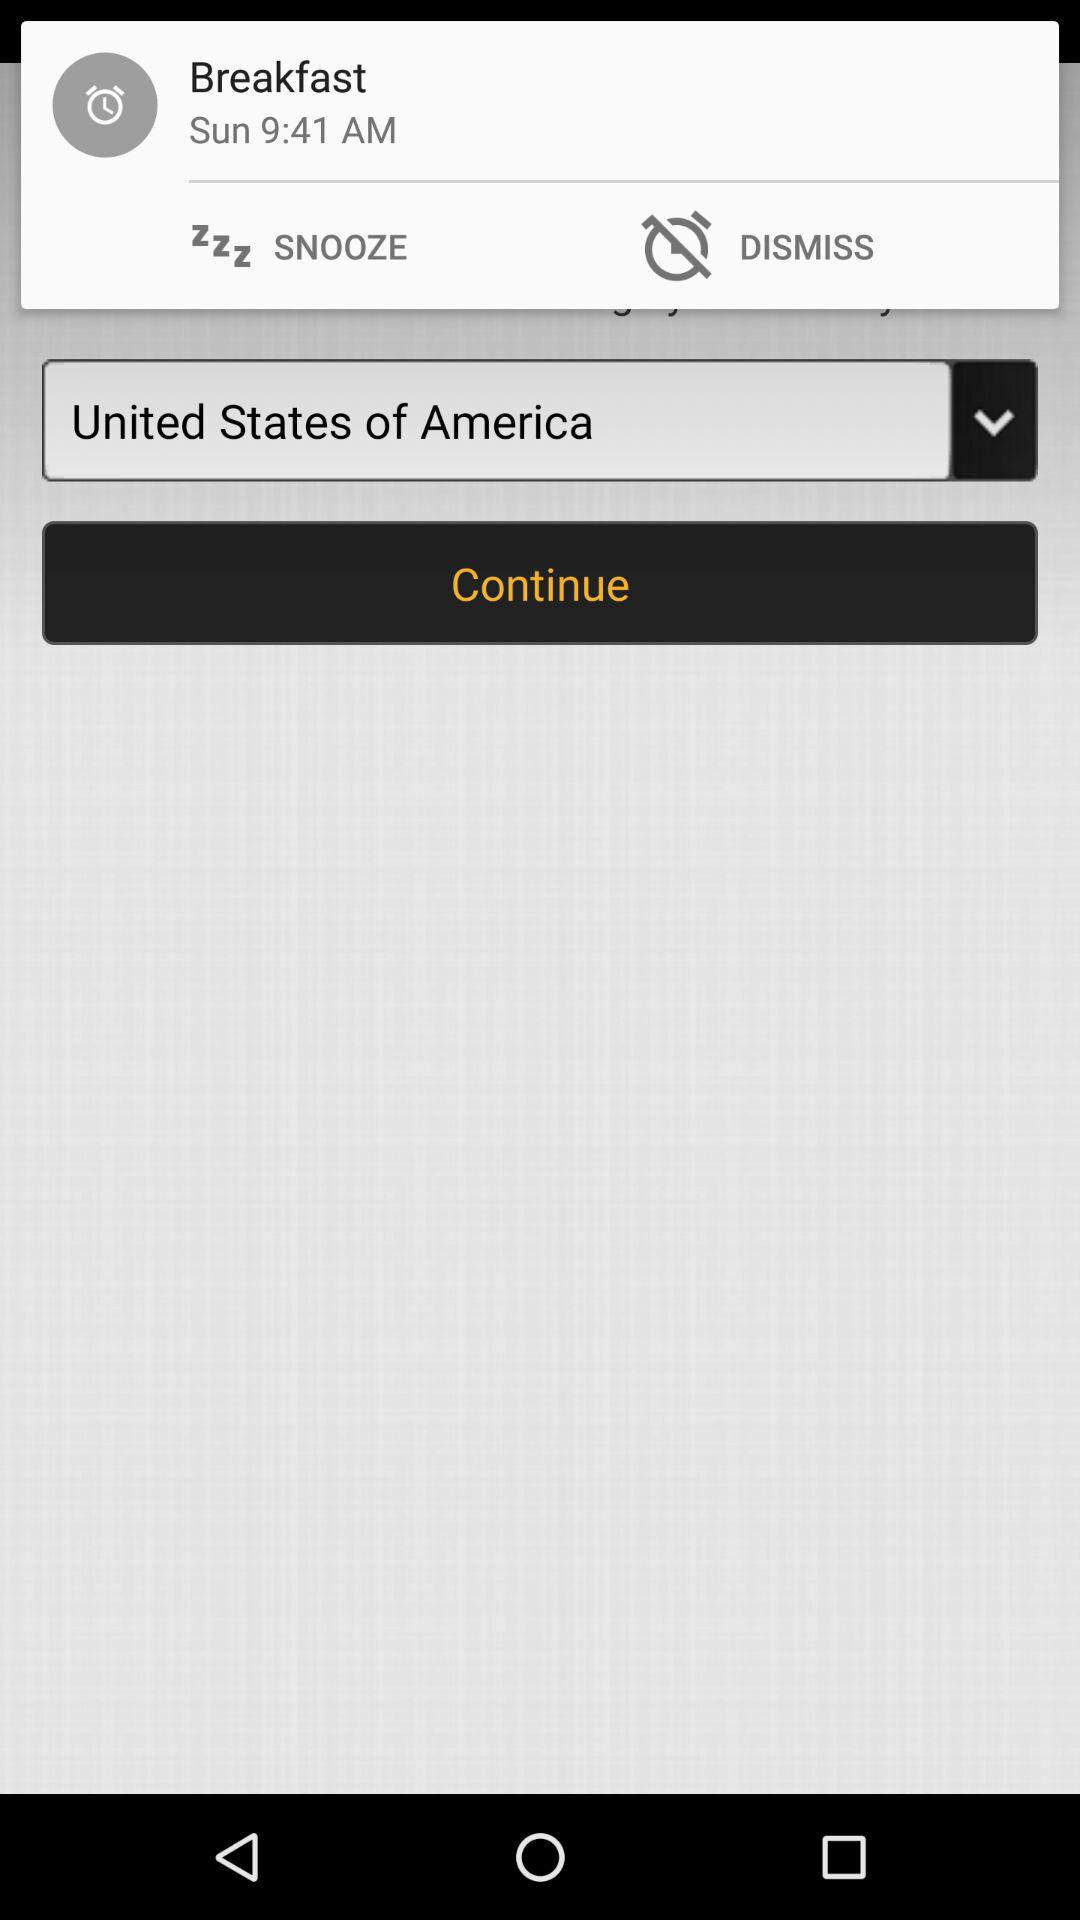On what day will the alarm sound? The alarm will sound on Sunday. 